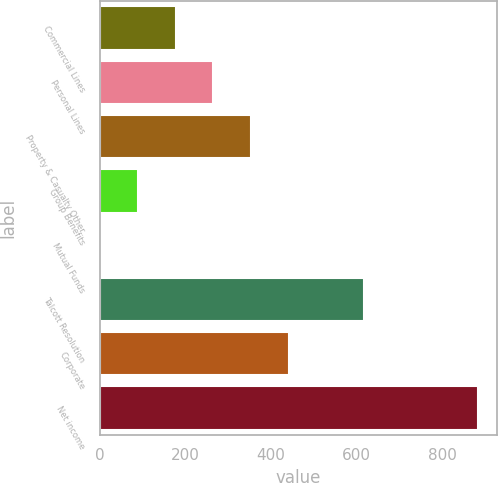Convert chart to OTSL. <chart><loc_0><loc_0><loc_500><loc_500><bar_chart><fcel>Commercial Lines<fcel>Personal Lines<fcel>Property & Casualty Other<fcel>Group Benefits<fcel>Mutual Funds<fcel>Talcott Resolution<fcel>Corporate<fcel>Net income<nl><fcel>177.6<fcel>265.9<fcel>354.2<fcel>89.3<fcel>1<fcel>617<fcel>442.5<fcel>884<nl></chart> 